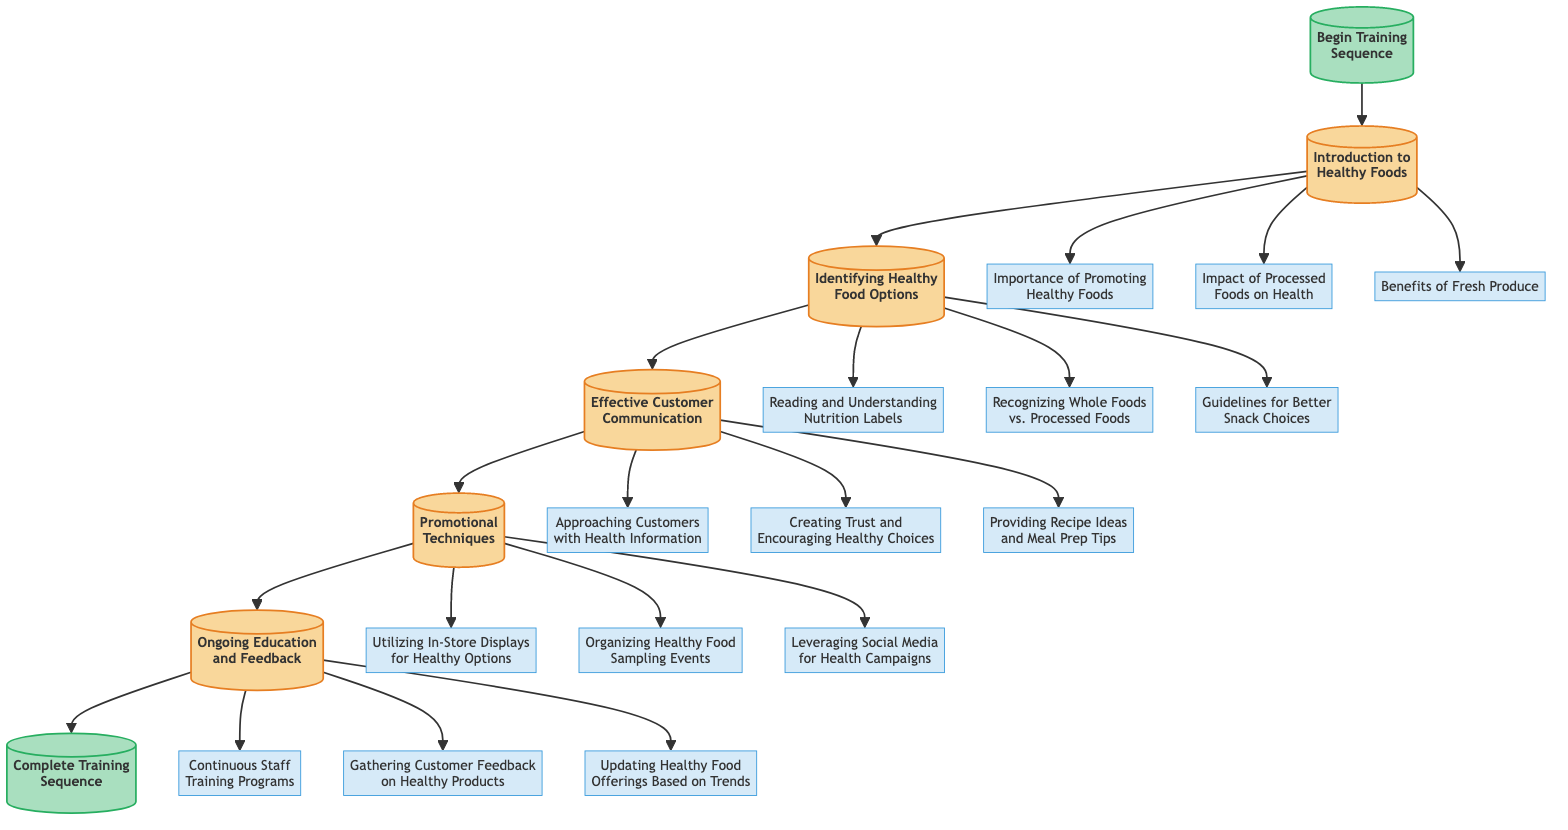What is the first module in the training sequence? The first module in the training sequence is indicated by the arrow leading from the "Begin Training Sequence" node to "Introduction to Healthy Foods."
Answer: Introduction to Healthy Foods How many content points are listed under "Promotional Techniques"? By examining the connections from the "Promotional Techniques" module, there are three content points: "Utilizing In-Store Displays for Healthy Options," "Organizing Healthy Food Sampling Events," and "Leveraging Social Media for Health Campaigns.”
Answer: 3 What is the last module before completing the training? The last module before the "Complete Training Sequence" node can be found by following the flowchart from "Ongoing Education and Feedback" to the end node, confirming it is the preceding module.
Answer: Ongoing Education and Feedback Which module discusses the importance of promoting healthy foods? By tracing the connections in the flowchart, the content point "Importance of Promoting Healthy Foods" is connected to the "Introduction to Healthy Foods" module, which covers this topic.
Answer: Introduction to Healthy Foods What follows after "Effective Customer Communication"? The flowchart shows an arrow leading from "Effective Customer Communication" to "Promotional Techniques," indicating the next step in the sequence after this module.
Answer: Promotional Techniques How many modules are included in the training sequence? Counting the modules listed in the flowchart, we have five distinct modules leading toward the end of the sequence.
Answer: 5 What is one key aspect of "Ongoing Education and Feedback"? From the connections made under "Ongoing Education and Feedback," one key aspect is "Continuous Staff Training Programs," highlighting the focus on ongoing improvement.
Answer: Continuous Staff Training Programs Which two modules focus on customer interaction? By reviewing the modules, we see "Effective Customer Communication" and "Ongoing Education and Feedback" both emphasize engaging with customers and enhancing their experience.
Answer: Effective Customer Communication, Ongoing Education and Feedback What content is covered in the "Identifying Healthy Food Options" module? The connections from "Identifying Healthy Food Options" show three specific content points: "Reading and Understanding Nutrition Labels," "Recognizing Whole Foods vs. Processed Foods," and "Guidelines for Better Snack Choices."
Answer: Reading and Understanding Nutrition Labels, Recognizing Whole Foods vs. Processed Foods, Guidelines for Better Snack Choices 